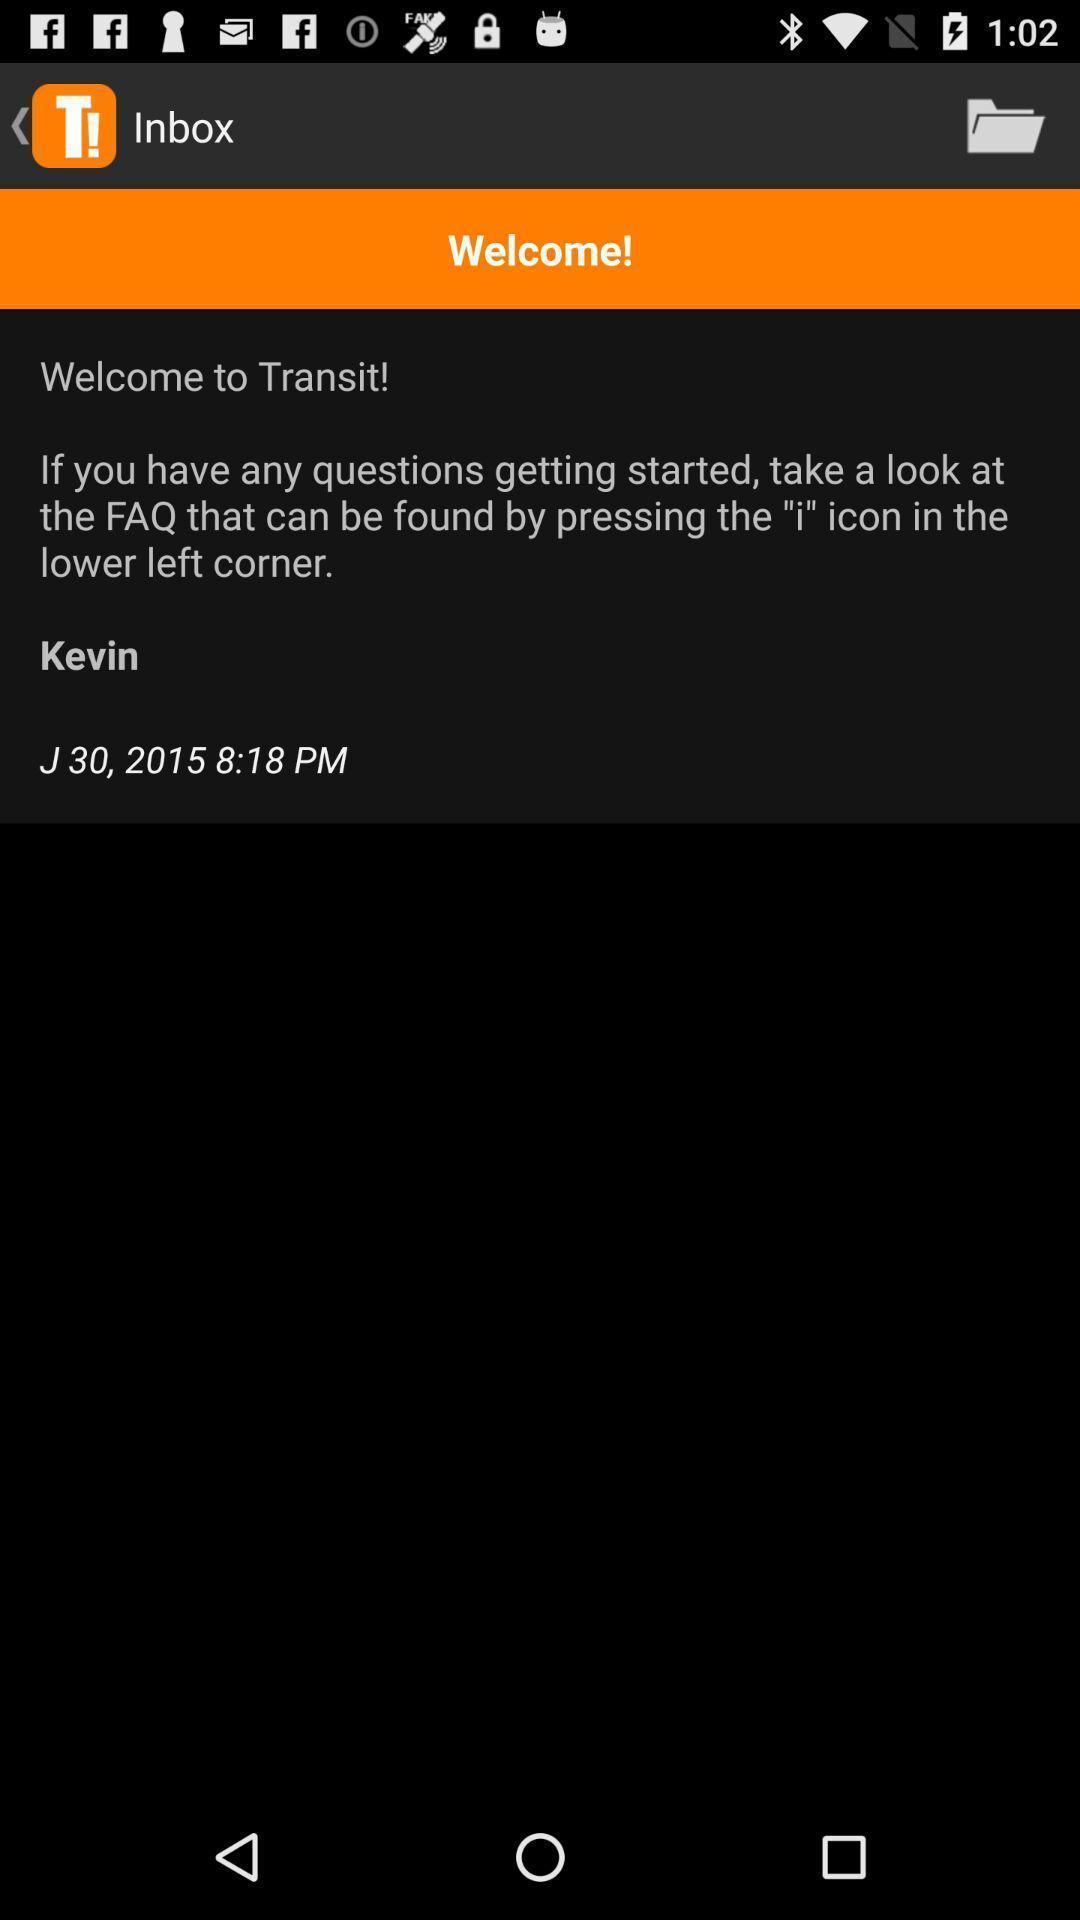Give me a summary of this screen capture. Welcome page of public transportation app. 